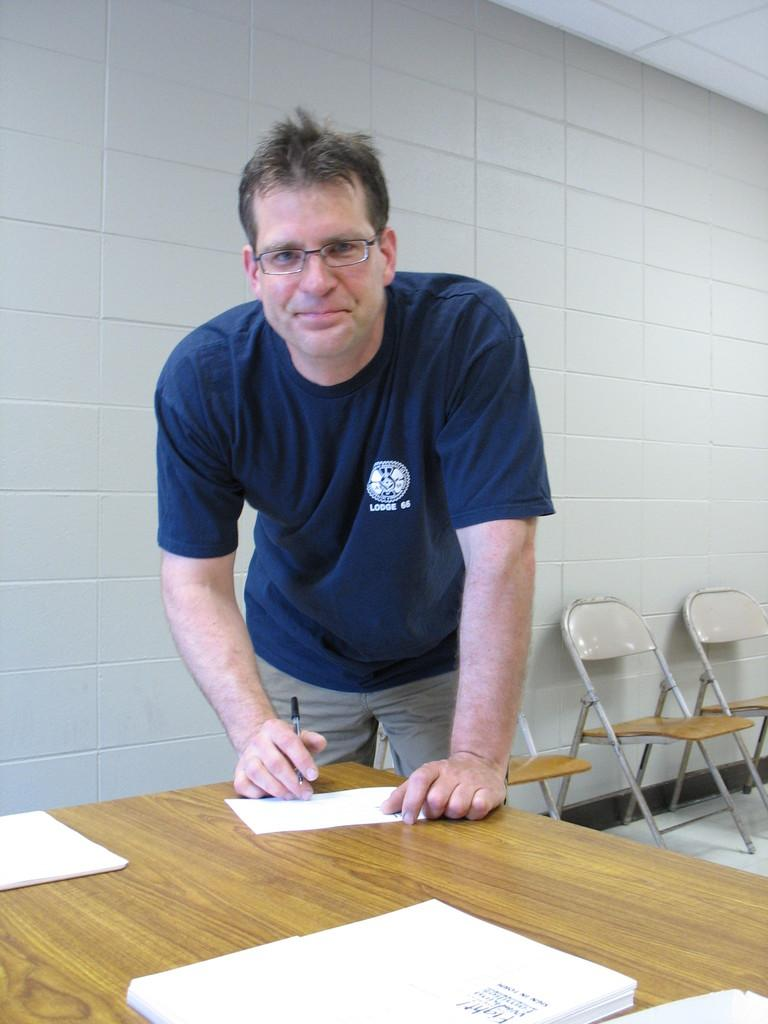Provide a one-sentence caption for the provided image. A man wearing a blue shirt reading LODGE 66 writes a note. 